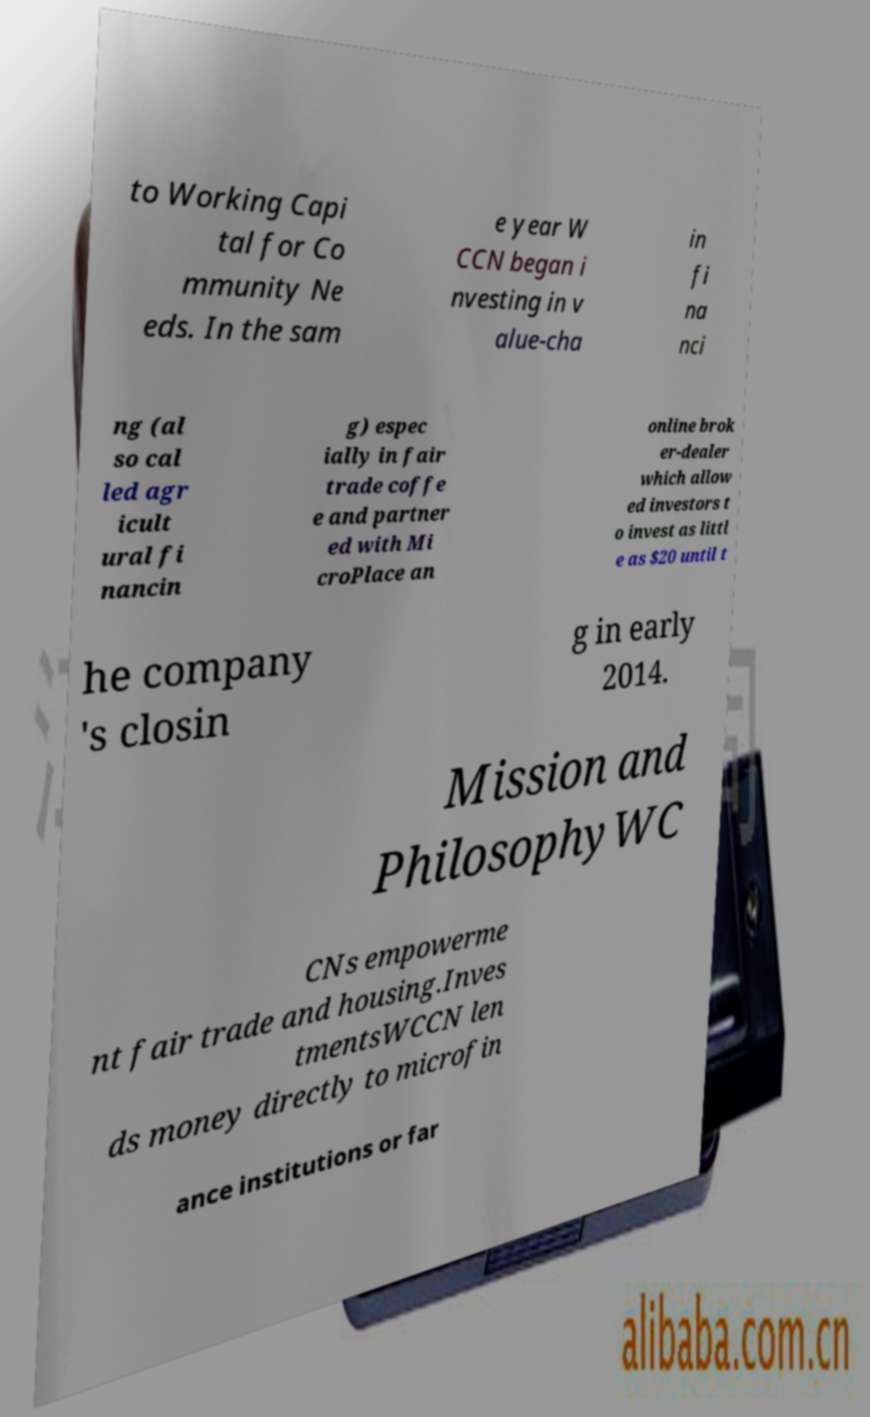Can you read and provide the text displayed in the image?This photo seems to have some interesting text. Can you extract and type it out for me? to Working Capi tal for Co mmunity Ne eds. In the sam e year W CCN began i nvesting in v alue-cha in fi na nci ng (al so cal led agr icult ural fi nancin g) espec ially in fair trade coffe e and partner ed with Mi croPlace an online brok er-dealer which allow ed investors t o invest as littl e as $20 until t he company 's closin g in early 2014. Mission and PhilosophyWC CNs empowerme nt fair trade and housing.Inves tmentsWCCN len ds money directly to microfin ance institutions or far 